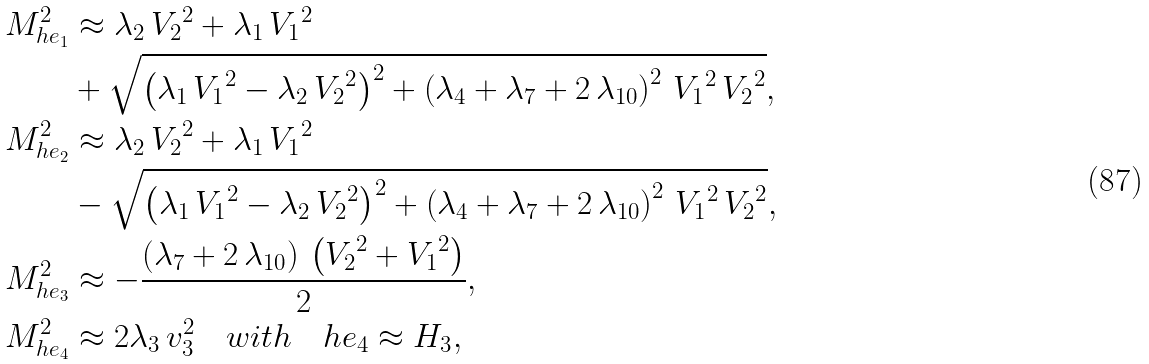Convert formula to latex. <formula><loc_0><loc_0><loc_500><loc_500>M _ { h e _ { 1 } } ^ { 2 } & \approx { \lambda _ { 2 } } \, { V _ { 2 } } ^ { 2 } + { \lambda _ { 1 } } \, { V _ { 1 } } ^ { 2 } \\ & + \sqrt { \left ( { \lambda _ { 1 } } \, { V _ { 1 } } ^ { 2 } - { \lambda _ { 2 } } \, { V _ { 2 } } ^ { 2 } \right ) ^ { 2 } + \left ( \lambda _ { 4 } + \lambda _ { 7 } + 2 \, \lambda _ { 1 0 } \right ) ^ { 2 } \, { V _ { 1 } } ^ { 2 } \, { V _ { 2 } } ^ { 2 } } , \\ M _ { h e _ { 2 } } ^ { 2 } & \approx { \lambda _ { 2 } } \, { V _ { 2 } } ^ { 2 } + { \lambda _ { 1 } } \, { V _ { 1 } } ^ { 2 } \\ & - \sqrt { \left ( { \lambda _ { 1 } } \, { V _ { 1 } } ^ { 2 } - { \lambda _ { 2 } } \, { V _ { 2 } } ^ { 2 } \right ) ^ { 2 } + \left ( \lambda _ { 4 } + \lambda _ { 7 } + 2 \, \lambda _ { 1 0 } \right ) ^ { 2 } \, { V _ { 1 } } ^ { 2 } \, { V _ { 2 } } ^ { 2 } } , \\ M _ { h e _ { 3 } } ^ { 2 } & \approx - { \frac { \left ( { \lambda _ { 7 } } + 2 \, { \lambda _ { 1 0 } } \right ) \, \left ( { V _ { 2 } } ^ { 2 } + { V _ { 1 } } ^ { 2 } \right ) } { 2 } } , \\ M _ { h e _ { 4 } } ^ { 2 } & \approx 2 \lambda _ { 3 } \, v _ { 3 } ^ { 2 } \quad w i t h \quad h e _ { 4 } \approx H _ { 3 } ,</formula> 